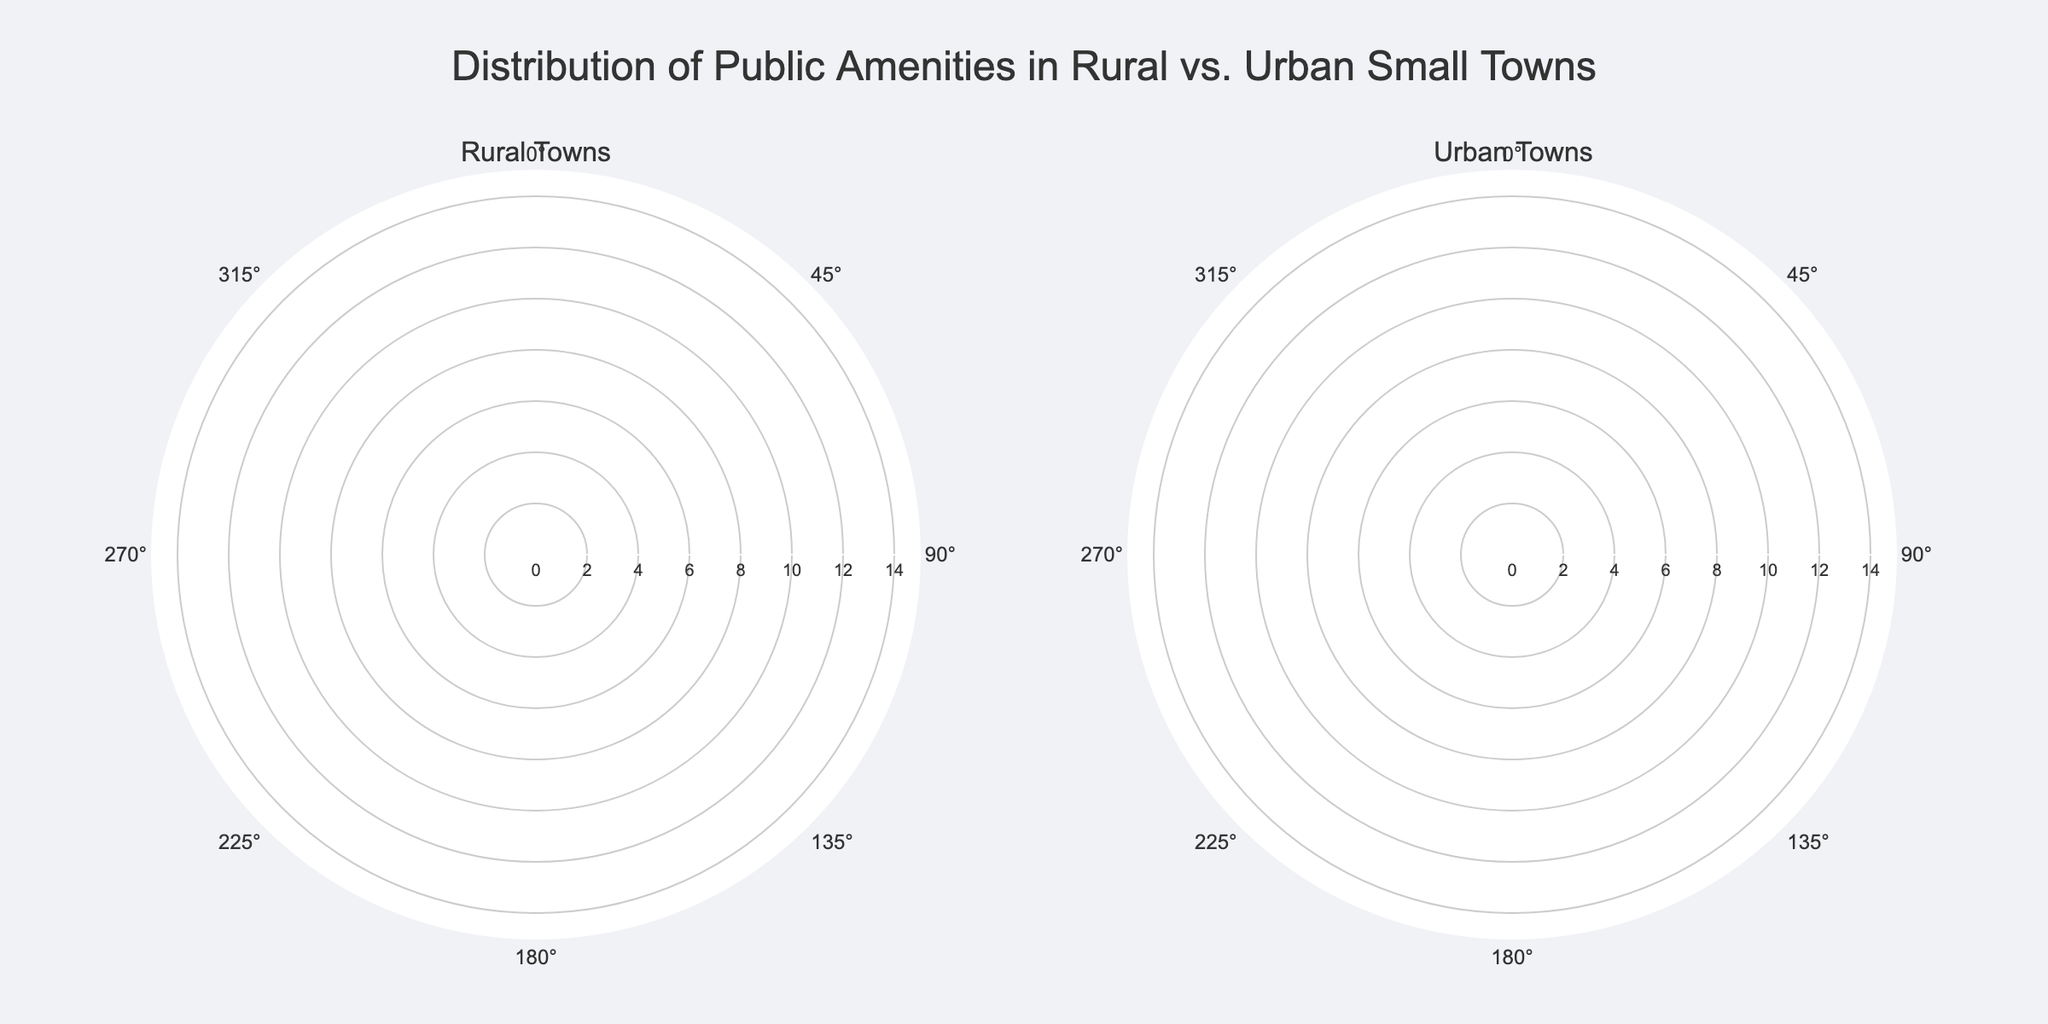What is the title of the figure? The title is displayed at the top of the figure and usually summarizes the primary theme or findings.
Answer: Distribution of Public Amenities in Rural vs. Urban Small Towns What color represents Parks on the chart? The colors for Parks can be observed by looking at the key or legend that identifies what each color corresponds to.
Answer: #FF6B6B Which municipality has the highest count of Healthcare Centers in urban towns? To compare the urban towns, look at the radial values for Healthcare Centers (represented by a specific color) and identify the town with the highest value.
Answer: Brookville How many rural towns have more than 5 parks? Inspect the radial values for Parks in the rural subplot and count how many municipalities have counts greater than 5.
Answer: Two What is the total number of libraries in urban towns? Sum the radial values of Libraries in the urban subplot for each urban town.
Answer: 15 How does the count of Parks compare between urban and rural towns in the municipality of Canton? Examine the Parks counts in Canton for both rural and urban towns and compare the values directly.
Answer: Urban has more Parks than rural Which urban town has the lowest number of Healthcare Centers? Check the radial values for Healthcare Centers in the urban subplot and identify the town with the smallest value.
Answer: Lakeside What is the average number of Parks across all municipalities in rural towns? Add up all the numbers of Parks in rural towns and divide by the number of municipalities. The computation is (5 + 4 + 6 + 7) / 4.
Answer: 5.5 Are there any municipalities where the count for Libraries is the same in both rural and urban settings? Compare the radial values for Libraries for each municipality in both subplots and identify any matches.
Answer: No 